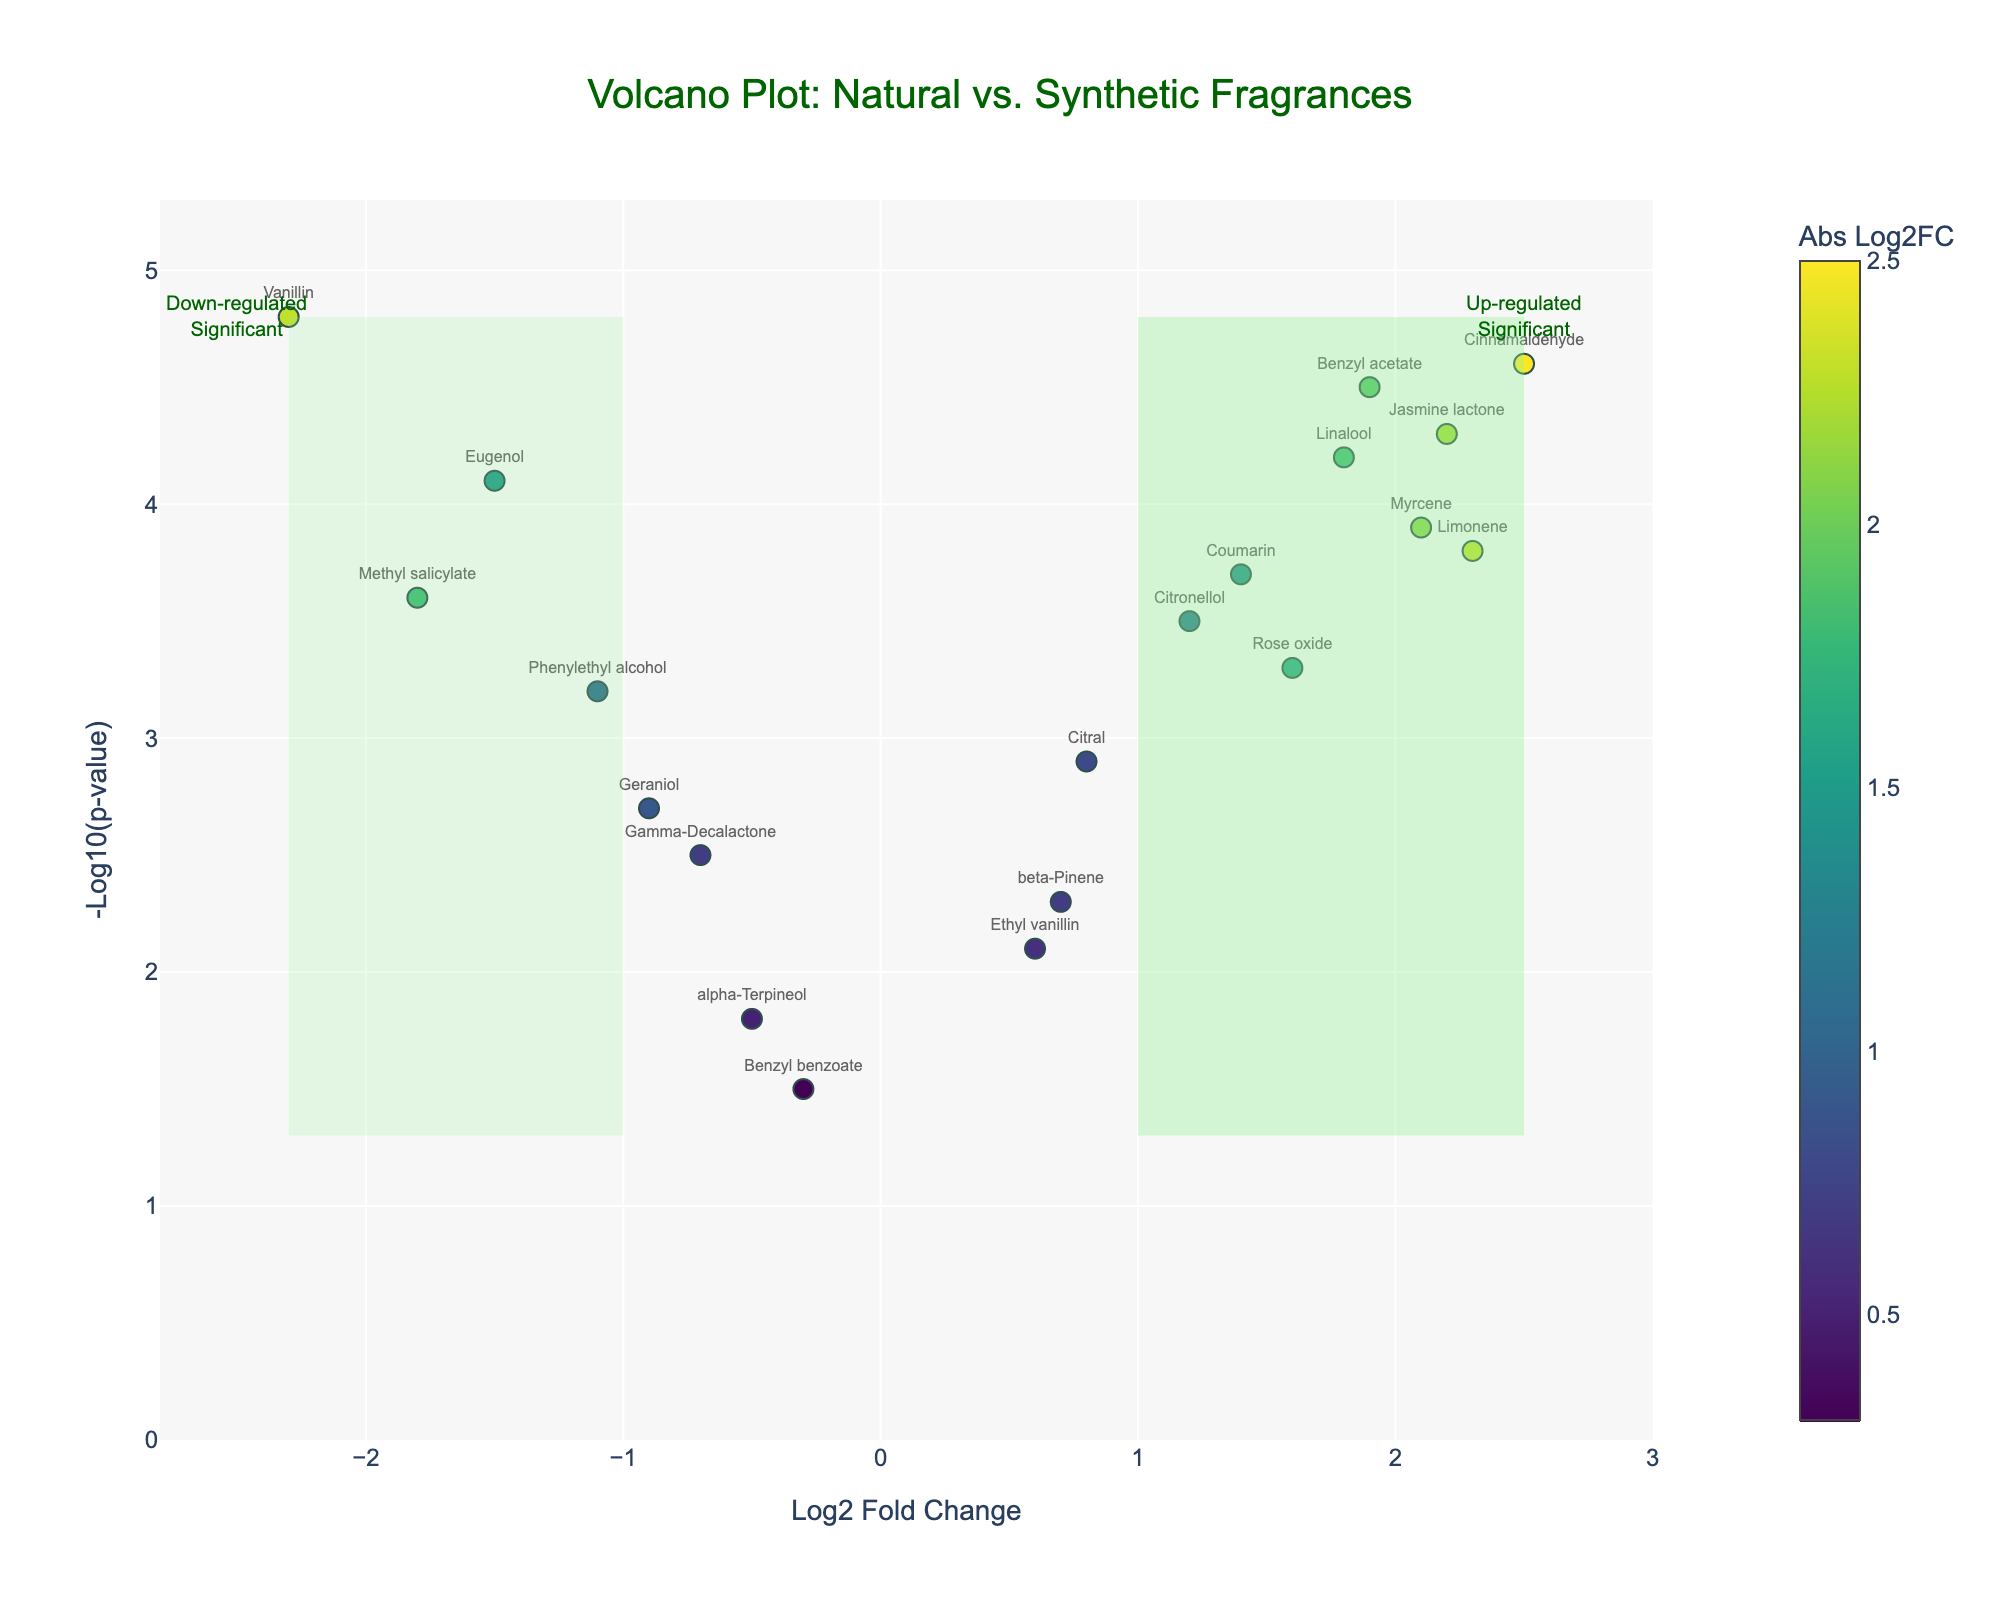What is the title of the figure? The title is usually displayed at the top of the plot and should be easy to see. In this plot, the title is clearly stated as "Volcano Plot: Natural vs. Synthetic Fragrances".
Answer: Volcano Plot: Natural vs. Synthetic Fragrances How many data points represent up-regulated and significant compounds? Up-regulated and significant compounds are those in the top right rectangle shaded light green. Examine all markers in that section to count them. The compounds in this region are Limonene, Linalool, Citronellol, Benzyl acetate, Myrcene, Coumarin, Jasmine lactone, and Cinnamaldehyde.
Answer: 8 Which compound has the highest Log2FoldChange? To determine this, look for the point farthest to the right on the x-axis, as the x-axis represents Log2FoldChange. Cinnamaldehyde is the farthest to the right.
Answer: Cinnamaldehyde What is the Log2FoldChange and -Log10(p-value) for Vanillin? Locate Vanillin on the plot and refer to its x (Log2FoldChange) and y (-Log10(p-value)) positions. Hover text can also provide this information. Vanillin's coordinates are (-2.3, 4.8).
Answer: Log2FoldChange: -2.3, -Log10(p-value): 4.8 How many compounds have a positive Log2FoldChange and a negative log10(p-value) greater than 3? Compounds meeting these criteria will be in the top right section of the plot (indicating significance) and have a positive x value. Identify compounds in this region (Limonene, Linalool, Citronellol, Benzyl acetate, Myrcene, Coumarin, Jasmine lactone, and Cinnamaldehyde).
Answer: 8 What does the red dashed horizontal line signify? The red dashed horizontal line represents a threshold in the plot. In this case, it signifies the p-value threshold which corresponds to -log10(0.05). Any point above this line represents a p-value less than 0.05, indicating statistical significance.
Answer: p-value threshold (-log10(0.05)) Which compound has a negative Log2FoldChange but is above the significance threshold? Examine the compounds to the left of the vertical y-axis at -1 and above the horizontal threshold at 1.3. Compounds meeting these criteria are Eugenol, Vanillin, and Methyl salicylate.
Answer: Eugenol, Vanillin, Methyl salicylate Which data point has the highest p-value significance? The highest significance would correspond to the largest y value (-Log10(p-value)). The point with the highest y value is Vanillin.
Answer: Vanillin What color indicates the highest absolute Log2FoldChange value? Colors correspond to the magnitude of absolute Log2FoldChange, and a Viridis color scale is used. The highest absolute values are typically darkest on this scale. The dark green/blue colors are indicative of the highest absolute Log2FoldChange values.
Answer: dark green/blue 